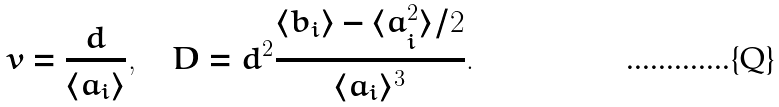<formula> <loc_0><loc_0><loc_500><loc_500>v = \frac { d } { \langle a _ { i } \rangle } , \quad D = d ^ { 2 } \frac { \langle b _ { i } \rangle - \langle a _ { i } ^ { 2 } \rangle / 2 } { \langle a _ { i } \rangle ^ { 3 } } .</formula> 